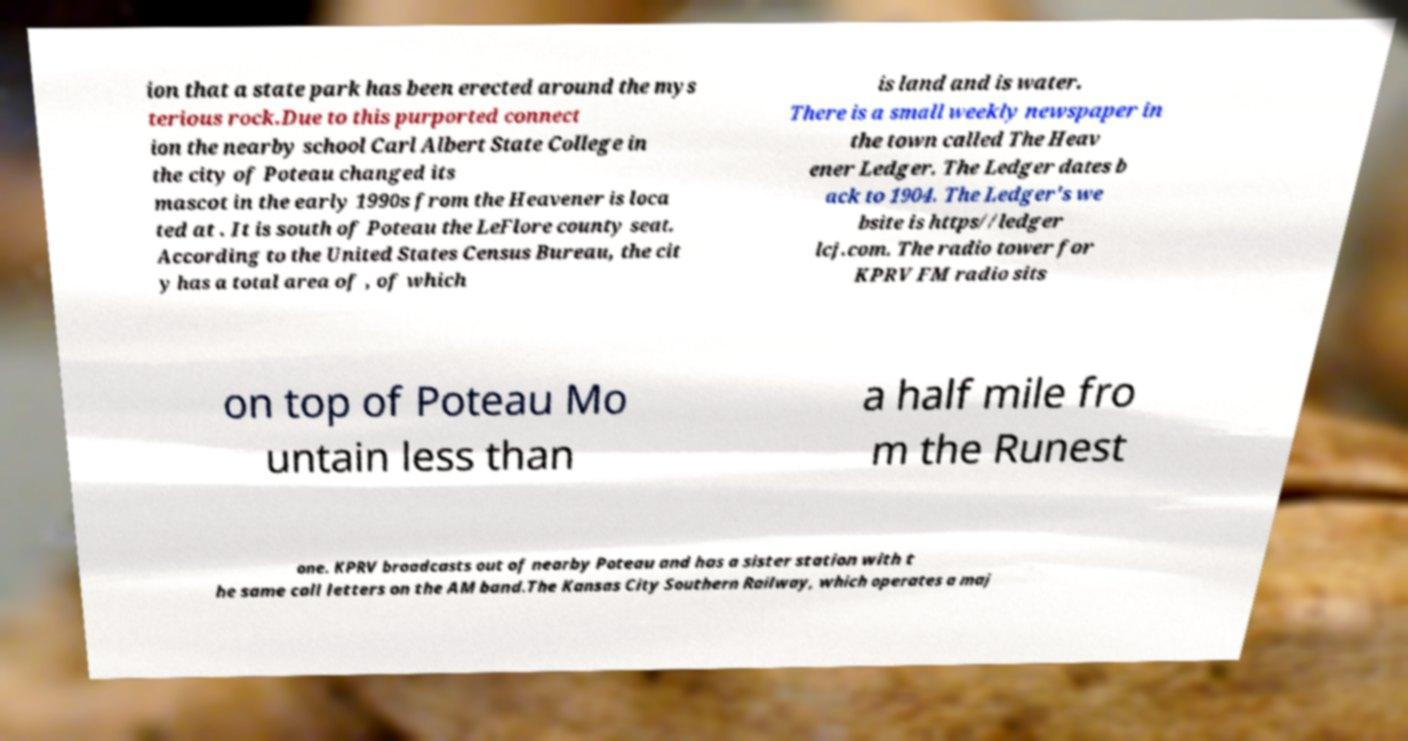What messages or text are displayed in this image? I need them in a readable, typed format. ion that a state park has been erected around the mys terious rock.Due to this purported connect ion the nearby school Carl Albert State College in the city of Poteau changed its mascot in the early 1990s from the Heavener is loca ted at . It is south of Poteau the LeFlore county seat. According to the United States Census Bureau, the cit y has a total area of , of which is land and is water. There is a small weekly newspaper in the town called The Heav ener Ledger. The Ledger dates b ack to 1904. The Ledger's we bsite is https//ledger lcj.com. The radio tower for KPRV FM radio sits on top of Poteau Mo untain less than a half mile fro m the Runest one. KPRV broadcasts out of nearby Poteau and has a sister station with t he same call letters on the AM band.The Kansas City Southern Railway, which operates a maj 